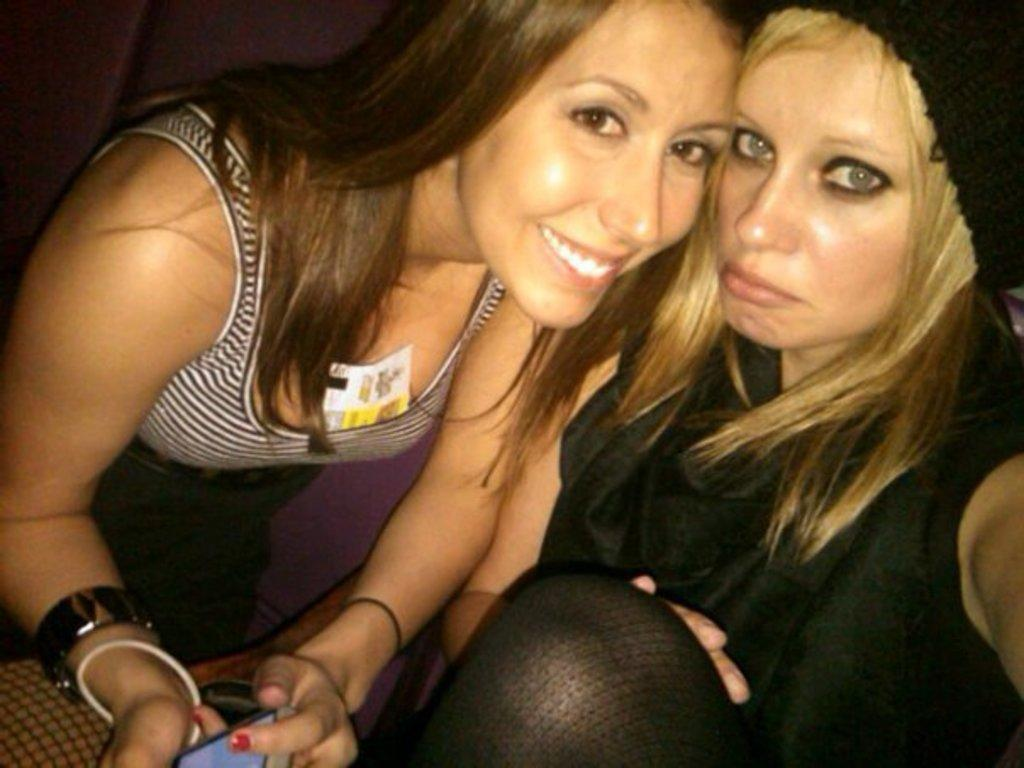How many people are present in the image? There are two persons in the image. What can be observed about the attire of the persons in the image? The persons are wearing clothes. What type of form does the soda take in the image? There is no soda present in the image. What trick can be seen being performed by the persons in the image? There is no trick being performed by the persons in the image; they are simply standing or interacting. 